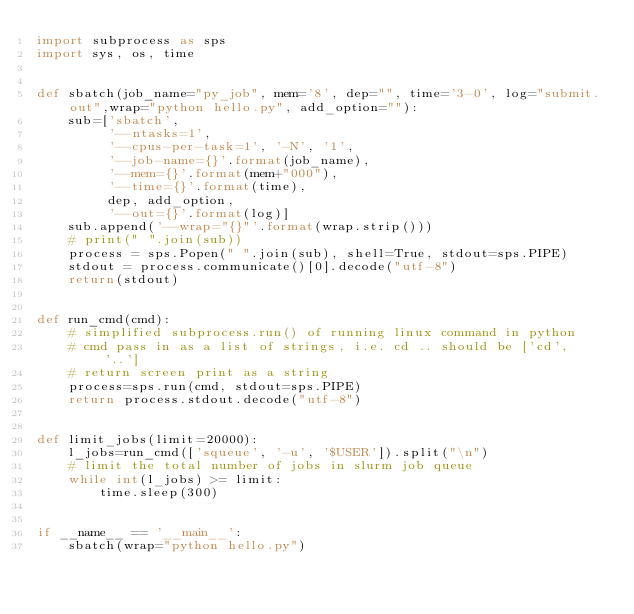<code> <loc_0><loc_0><loc_500><loc_500><_Python_>import subprocess as sps
import sys, os, time


def sbatch(job_name="py_job", mem='8', dep="", time='3-0', log="submit.out",wrap="python hello.py", add_option=""):
    sub=['sbatch',
         '--ntasks=1',
         '--cpus-per-task=1', '-N', '1',
         '--job-name={}'.format(job_name),
         '--mem={}'.format(mem+"000"),
         '--time={}'.format(time),
         dep, add_option,
         '--out={}'.format(log)]
    sub.append('--wrap="{}"'.format(wrap.strip()))
    # print(" ".join(sub))
    process = sps.Popen(" ".join(sub), shell=True, stdout=sps.PIPE)
    stdout = process.communicate()[0].decode("utf-8")
    return(stdout)


def run_cmd(cmd):
    # simplified subprocess.run() of running linux command in python
    # cmd pass in as a list of strings, i.e. cd .. should be ['cd', '..']
    # return screen print as a string
    process=sps.run(cmd, stdout=sps.PIPE)
    return process.stdout.decode("utf-8")


def limit_jobs(limit=20000):
    l_jobs=run_cmd(['squeue', '-u', '$USER']).split("\n")
    # limit the total number of jobs in slurm job queue
    while int(l_jobs) >= limit:
        time.sleep(300)


if __name__ == '__main__':
    sbatch(wrap="python hello.py")
</code> 